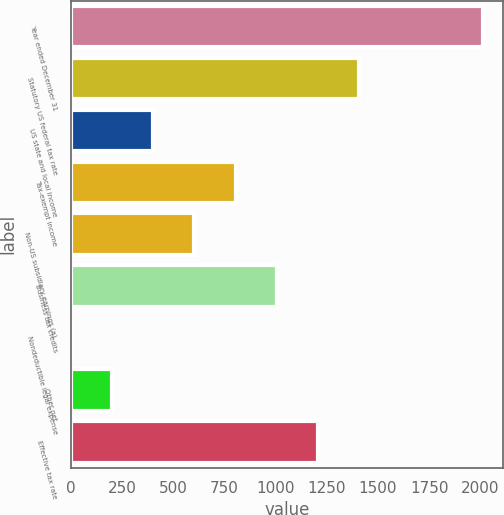<chart> <loc_0><loc_0><loc_500><loc_500><bar_chart><fcel>Year ended December 31<fcel>Statutory US federal tax rate<fcel>US state and local income<fcel>Tax-exempt income<fcel>Non-US subsidiary earnings (a)<fcel>Business tax credits<fcel>Nondeductible legal expense<fcel>Other net<fcel>Effective tax rate<nl><fcel>2012<fcel>1408.46<fcel>402.56<fcel>804.92<fcel>603.74<fcel>1006.1<fcel>0.2<fcel>201.38<fcel>1207.28<nl></chart> 